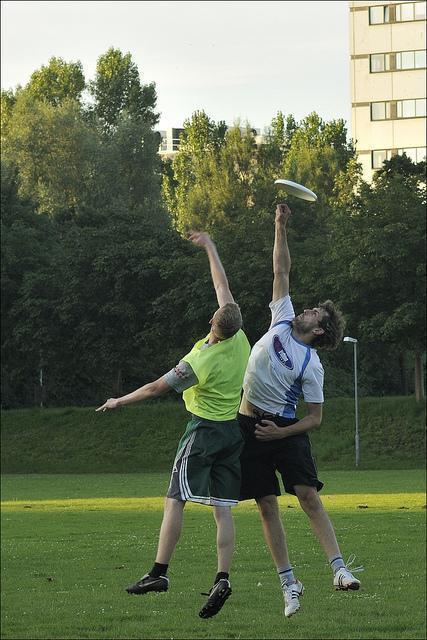What allows this toy to fly?
Select the accurate response from the four choices given to answer the question.
Options: Lift, fan, string, battery. Lift. 